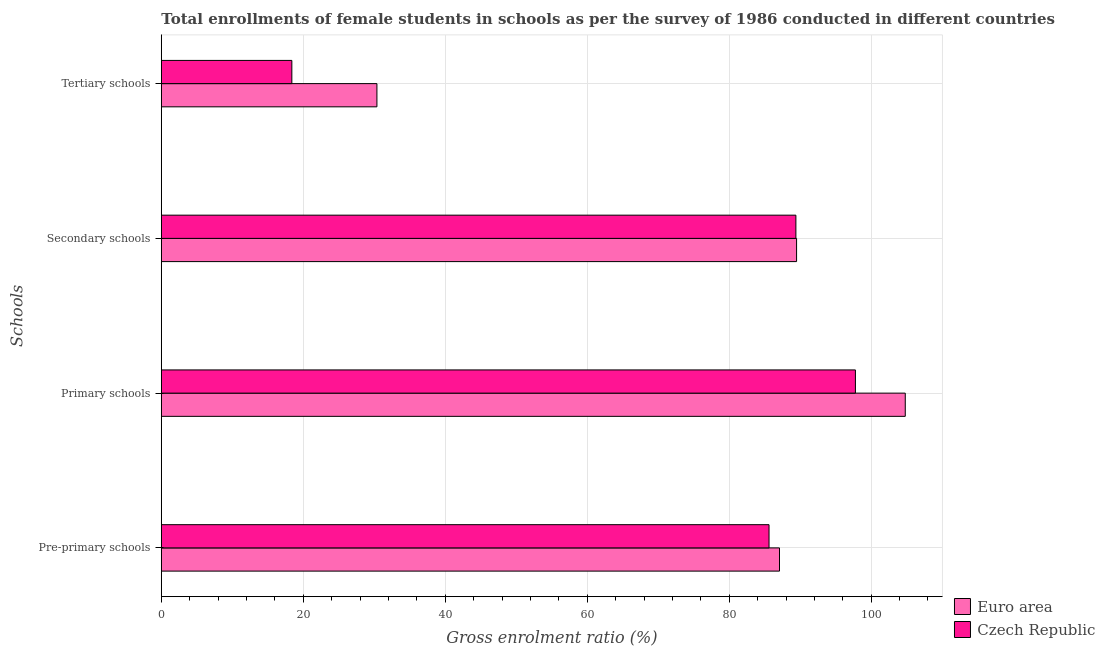What is the label of the 4th group of bars from the top?
Offer a very short reply. Pre-primary schools. What is the gross enrolment ratio(female) in primary schools in Czech Republic?
Provide a succinct answer. 97.78. Across all countries, what is the maximum gross enrolment ratio(female) in pre-primary schools?
Your response must be concise. 87.08. Across all countries, what is the minimum gross enrolment ratio(female) in secondary schools?
Your response must be concise. 89.39. In which country was the gross enrolment ratio(female) in primary schools minimum?
Provide a short and direct response. Czech Republic. What is the total gross enrolment ratio(female) in primary schools in the graph?
Give a very brief answer. 202.58. What is the difference between the gross enrolment ratio(female) in primary schools in Euro area and that in Czech Republic?
Provide a short and direct response. 7.02. What is the difference between the gross enrolment ratio(female) in tertiary schools in Euro area and the gross enrolment ratio(female) in pre-primary schools in Czech Republic?
Give a very brief answer. -55.24. What is the average gross enrolment ratio(female) in pre-primary schools per country?
Provide a succinct answer. 86.35. What is the difference between the gross enrolment ratio(female) in primary schools and gross enrolment ratio(female) in secondary schools in Euro area?
Your answer should be compact. 15.31. In how many countries, is the gross enrolment ratio(female) in primary schools greater than 104 %?
Your response must be concise. 1. What is the ratio of the gross enrolment ratio(female) in secondary schools in Euro area to that in Czech Republic?
Give a very brief answer. 1. Is the gross enrolment ratio(female) in secondary schools in Euro area less than that in Czech Republic?
Your answer should be very brief. No. What is the difference between the highest and the second highest gross enrolment ratio(female) in secondary schools?
Give a very brief answer. 0.1. What is the difference between the highest and the lowest gross enrolment ratio(female) in primary schools?
Provide a succinct answer. 7.02. In how many countries, is the gross enrolment ratio(female) in secondary schools greater than the average gross enrolment ratio(female) in secondary schools taken over all countries?
Offer a very short reply. 1. Is the sum of the gross enrolment ratio(female) in pre-primary schools in Czech Republic and Euro area greater than the maximum gross enrolment ratio(female) in secondary schools across all countries?
Provide a short and direct response. Yes. Is it the case that in every country, the sum of the gross enrolment ratio(female) in pre-primary schools and gross enrolment ratio(female) in primary schools is greater than the sum of gross enrolment ratio(female) in tertiary schools and gross enrolment ratio(female) in secondary schools?
Make the answer very short. Yes. What does the 1st bar from the top in Secondary schools represents?
Give a very brief answer. Czech Republic. Is it the case that in every country, the sum of the gross enrolment ratio(female) in pre-primary schools and gross enrolment ratio(female) in primary schools is greater than the gross enrolment ratio(female) in secondary schools?
Offer a terse response. Yes. Are all the bars in the graph horizontal?
Provide a succinct answer. Yes. How many countries are there in the graph?
Your response must be concise. 2. Does the graph contain any zero values?
Make the answer very short. No. Does the graph contain grids?
Your response must be concise. Yes. Where does the legend appear in the graph?
Provide a short and direct response. Bottom right. How many legend labels are there?
Make the answer very short. 2. What is the title of the graph?
Give a very brief answer. Total enrollments of female students in schools as per the survey of 1986 conducted in different countries. What is the label or title of the X-axis?
Provide a succinct answer. Gross enrolment ratio (%). What is the label or title of the Y-axis?
Your answer should be compact. Schools. What is the Gross enrolment ratio (%) of Euro area in Pre-primary schools?
Provide a succinct answer. 87.08. What is the Gross enrolment ratio (%) in Czech Republic in Pre-primary schools?
Offer a terse response. 85.61. What is the Gross enrolment ratio (%) in Euro area in Primary schools?
Give a very brief answer. 104.8. What is the Gross enrolment ratio (%) in Czech Republic in Primary schools?
Your answer should be very brief. 97.78. What is the Gross enrolment ratio (%) in Euro area in Secondary schools?
Make the answer very short. 89.49. What is the Gross enrolment ratio (%) in Czech Republic in Secondary schools?
Offer a very short reply. 89.39. What is the Gross enrolment ratio (%) of Euro area in Tertiary schools?
Make the answer very short. 30.37. What is the Gross enrolment ratio (%) in Czech Republic in Tertiary schools?
Provide a short and direct response. 18.39. Across all Schools, what is the maximum Gross enrolment ratio (%) in Euro area?
Your response must be concise. 104.8. Across all Schools, what is the maximum Gross enrolment ratio (%) of Czech Republic?
Offer a very short reply. 97.78. Across all Schools, what is the minimum Gross enrolment ratio (%) of Euro area?
Your answer should be very brief. 30.37. Across all Schools, what is the minimum Gross enrolment ratio (%) of Czech Republic?
Provide a short and direct response. 18.39. What is the total Gross enrolment ratio (%) of Euro area in the graph?
Provide a short and direct response. 311.75. What is the total Gross enrolment ratio (%) of Czech Republic in the graph?
Your answer should be very brief. 291.17. What is the difference between the Gross enrolment ratio (%) in Euro area in Pre-primary schools and that in Primary schools?
Your answer should be compact. -17.72. What is the difference between the Gross enrolment ratio (%) in Czech Republic in Pre-primary schools and that in Primary schools?
Give a very brief answer. -12.17. What is the difference between the Gross enrolment ratio (%) of Euro area in Pre-primary schools and that in Secondary schools?
Offer a terse response. -2.41. What is the difference between the Gross enrolment ratio (%) of Czech Republic in Pre-primary schools and that in Secondary schools?
Your answer should be compact. -3.78. What is the difference between the Gross enrolment ratio (%) in Euro area in Pre-primary schools and that in Tertiary schools?
Offer a terse response. 56.71. What is the difference between the Gross enrolment ratio (%) in Czech Republic in Pre-primary schools and that in Tertiary schools?
Offer a very short reply. 67.22. What is the difference between the Gross enrolment ratio (%) of Euro area in Primary schools and that in Secondary schools?
Provide a short and direct response. 15.31. What is the difference between the Gross enrolment ratio (%) of Czech Republic in Primary schools and that in Secondary schools?
Make the answer very short. 8.39. What is the difference between the Gross enrolment ratio (%) of Euro area in Primary schools and that in Tertiary schools?
Provide a succinct answer. 74.43. What is the difference between the Gross enrolment ratio (%) of Czech Republic in Primary schools and that in Tertiary schools?
Your response must be concise. 79.39. What is the difference between the Gross enrolment ratio (%) in Euro area in Secondary schools and that in Tertiary schools?
Ensure brevity in your answer.  59.12. What is the difference between the Gross enrolment ratio (%) in Czech Republic in Secondary schools and that in Tertiary schools?
Your response must be concise. 71. What is the difference between the Gross enrolment ratio (%) in Euro area in Pre-primary schools and the Gross enrolment ratio (%) in Czech Republic in Primary schools?
Provide a short and direct response. -10.69. What is the difference between the Gross enrolment ratio (%) of Euro area in Pre-primary schools and the Gross enrolment ratio (%) of Czech Republic in Secondary schools?
Offer a terse response. -2.31. What is the difference between the Gross enrolment ratio (%) in Euro area in Pre-primary schools and the Gross enrolment ratio (%) in Czech Republic in Tertiary schools?
Provide a succinct answer. 68.7. What is the difference between the Gross enrolment ratio (%) in Euro area in Primary schools and the Gross enrolment ratio (%) in Czech Republic in Secondary schools?
Provide a succinct answer. 15.41. What is the difference between the Gross enrolment ratio (%) of Euro area in Primary schools and the Gross enrolment ratio (%) of Czech Republic in Tertiary schools?
Keep it short and to the point. 86.41. What is the difference between the Gross enrolment ratio (%) in Euro area in Secondary schools and the Gross enrolment ratio (%) in Czech Republic in Tertiary schools?
Offer a terse response. 71.1. What is the average Gross enrolment ratio (%) of Euro area per Schools?
Your answer should be compact. 77.94. What is the average Gross enrolment ratio (%) in Czech Republic per Schools?
Your answer should be very brief. 72.79. What is the difference between the Gross enrolment ratio (%) of Euro area and Gross enrolment ratio (%) of Czech Republic in Pre-primary schools?
Provide a short and direct response. 1.48. What is the difference between the Gross enrolment ratio (%) of Euro area and Gross enrolment ratio (%) of Czech Republic in Primary schools?
Offer a terse response. 7.02. What is the difference between the Gross enrolment ratio (%) of Euro area and Gross enrolment ratio (%) of Czech Republic in Secondary schools?
Give a very brief answer. 0.1. What is the difference between the Gross enrolment ratio (%) of Euro area and Gross enrolment ratio (%) of Czech Republic in Tertiary schools?
Offer a terse response. 11.98. What is the ratio of the Gross enrolment ratio (%) in Euro area in Pre-primary schools to that in Primary schools?
Provide a succinct answer. 0.83. What is the ratio of the Gross enrolment ratio (%) of Czech Republic in Pre-primary schools to that in Primary schools?
Offer a terse response. 0.88. What is the ratio of the Gross enrolment ratio (%) in Euro area in Pre-primary schools to that in Secondary schools?
Your answer should be compact. 0.97. What is the ratio of the Gross enrolment ratio (%) in Czech Republic in Pre-primary schools to that in Secondary schools?
Give a very brief answer. 0.96. What is the ratio of the Gross enrolment ratio (%) of Euro area in Pre-primary schools to that in Tertiary schools?
Keep it short and to the point. 2.87. What is the ratio of the Gross enrolment ratio (%) of Czech Republic in Pre-primary schools to that in Tertiary schools?
Ensure brevity in your answer.  4.66. What is the ratio of the Gross enrolment ratio (%) of Euro area in Primary schools to that in Secondary schools?
Keep it short and to the point. 1.17. What is the ratio of the Gross enrolment ratio (%) of Czech Republic in Primary schools to that in Secondary schools?
Offer a terse response. 1.09. What is the ratio of the Gross enrolment ratio (%) of Euro area in Primary schools to that in Tertiary schools?
Give a very brief answer. 3.45. What is the ratio of the Gross enrolment ratio (%) in Czech Republic in Primary schools to that in Tertiary schools?
Offer a very short reply. 5.32. What is the ratio of the Gross enrolment ratio (%) in Euro area in Secondary schools to that in Tertiary schools?
Provide a short and direct response. 2.95. What is the ratio of the Gross enrolment ratio (%) of Czech Republic in Secondary schools to that in Tertiary schools?
Provide a succinct answer. 4.86. What is the difference between the highest and the second highest Gross enrolment ratio (%) of Euro area?
Give a very brief answer. 15.31. What is the difference between the highest and the second highest Gross enrolment ratio (%) in Czech Republic?
Give a very brief answer. 8.39. What is the difference between the highest and the lowest Gross enrolment ratio (%) of Euro area?
Your answer should be very brief. 74.43. What is the difference between the highest and the lowest Gross enrolment ratio (%) in Czech Republic?
Make the answer very short. 79.39. 